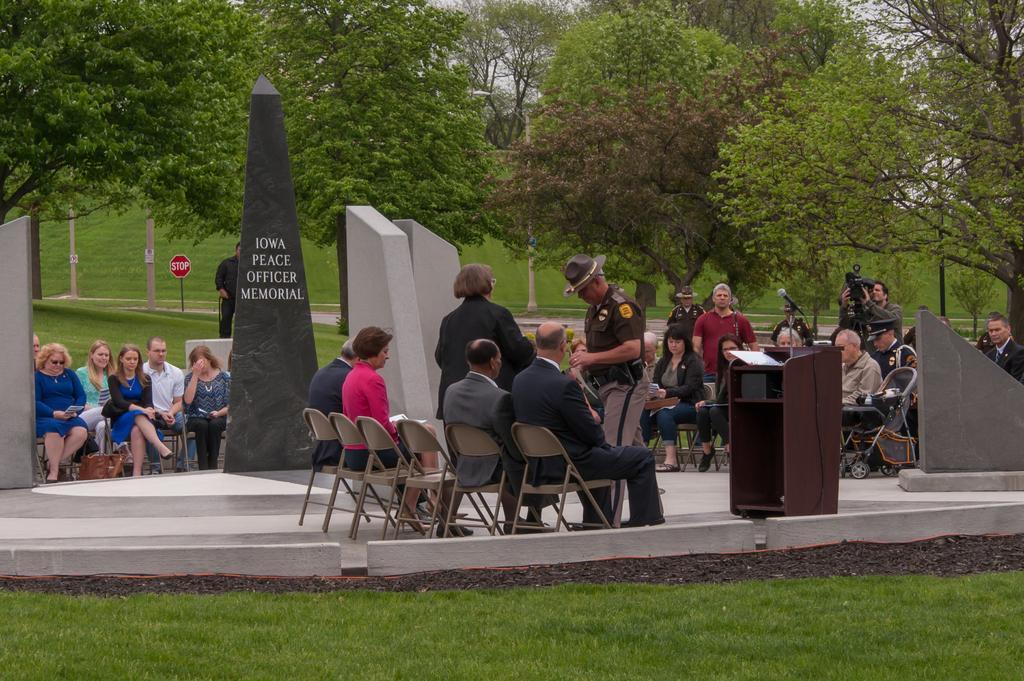How would you summarize this image in a sentence or two? There are four people sitting in chairs and there are two people standing in front of them and there are group of people sitting in chairs in front of them and there are trees and camera in the background. 